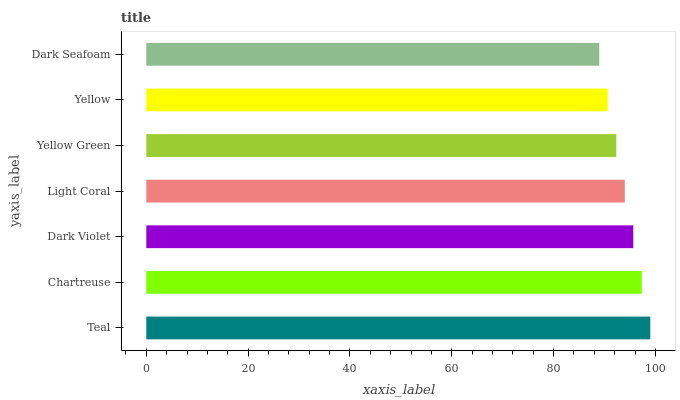Is Dark Seafoam the minimum?
Answer yes or no. Yes. Is Teal the maximum?
Answer yes or no. Yes. Is Chartreuse the minimum?
Answer yes or no. No. Is Chartreuse the maximum?
Answer yes or no. No. Is Teal greater than Chartreuse?
Answer yes or no. Yes. Is Chartreuse less than Teal?
Answer yes or no. Yes. Is Chartreuse greater than Teal?
Answer yes or no. No. Is Teal less than Chartreuse?
Answer yes or no. No. Is Light Coral the high median?
Answer yes or no. Yes. Is Light Coral the low median?
Answer yes or no. Yes. Is Dark Seafoam the high median?
Answer yes or no. No. Is Dark Seafoam the low median?
Answer yes or no. No. 